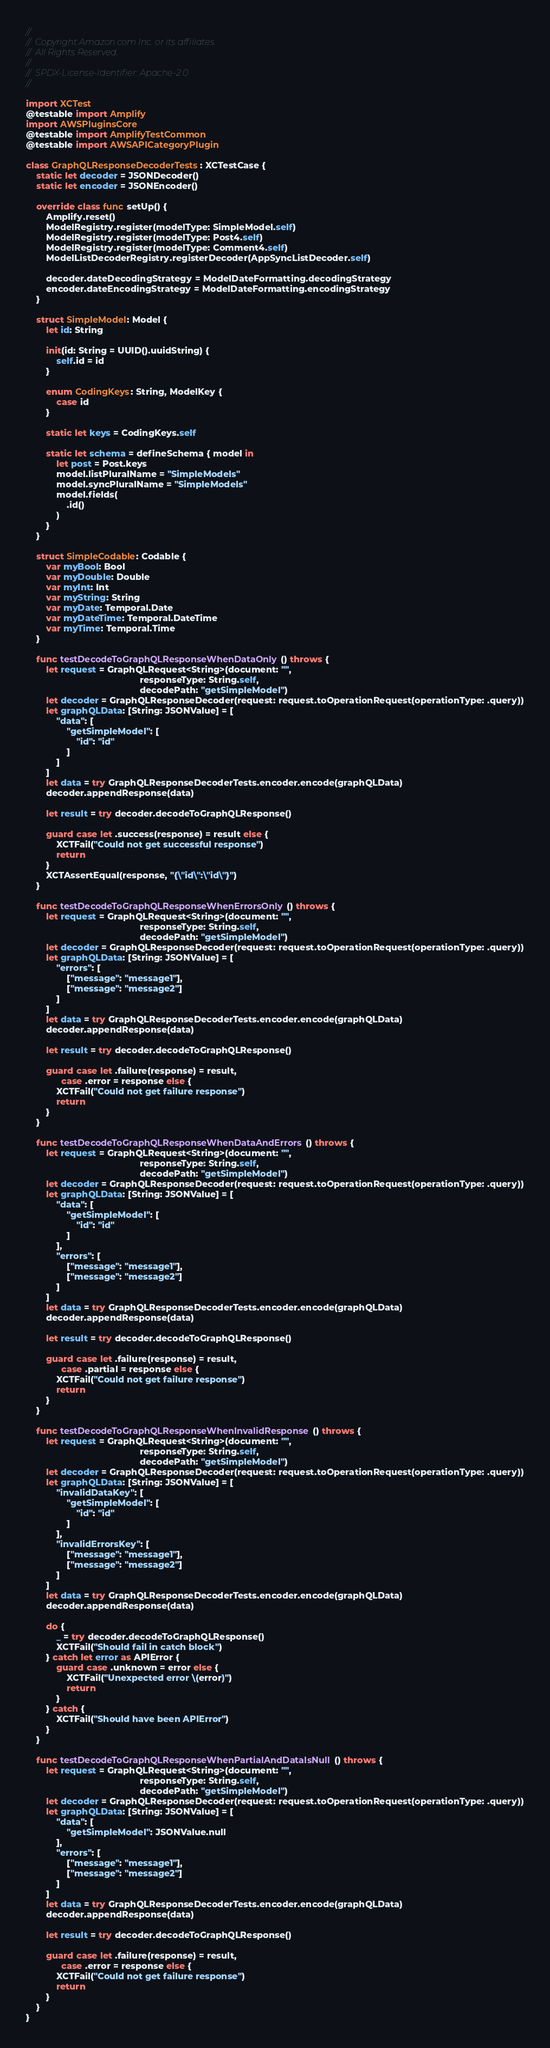Convert code to text. <code><loc_0><loc_0><loc_500><loc_500><_Swift_>//
// Copyright Amazon.com Inc. or its affiliates.
// All Rights Reserved.
//
// SPDX-License-Identifier: Apache-2.0
//

import XCTest
@testable import Amplify
import AWSPluginsCore
@testable import AmplifyTestCommon
@testable import AWSAPICategoryPlugin

class GraphQLResponseDecoderTests: XCTestCase {
    static let decoder = JSONDecoder()
    static let encoder = JSONEncoder()

    override class func setUp() {
        Amplify.reset()
        ModelRegistry.register(modelType: SimpleModel.self)
        ModelRegistry.register(modelType: Post4.self)
        ModelRegistry.register(modelType: Comment4.self)
        ModelListDecoderRegistry.registerDecoder(AppSyncListDecoder.self)

        decoder.dateDecodingStrategy = ModelDateFormatting.decodingStrategy
        encoder.dateEncodingStrategy = ModelDateFormatting.encodingStrategy
    }

    struct SimpleModel: Model {
        let id: String

        init(id: String = UUID().uuidString) {
            self.id = id
        }

        enum CodingKeys: String, ModelKey {
            case id
        }

        static let keys = CodingKeys.self

        static let schema = defineSchema { model in
            let post = Post.keys
            model.listPluralName = "SimpleModels"
            model.syncPluralName = "SimpleModels"
            model.fields(
                .id()
            )
        }
    }

    struct SimpleCodable: Codable {
        var myBool: Bool
        var myDouble: Double
        var myInt: Int
        var myString: String
        var myDate: Temporal.Date
        var myDateTime: Temporal.DateTime
        var myTime: Temporal.Time
    }

    func testDecodeToGraphQLResponseWhenDataOnly() throws {
        let request = GraphQLRequest<String>(document: "",
                                             responseType: String.self,
                                             decodePath: "getSimpleModel")
        let decoder = GraphQLResponseDecoder(request: request.toOperationRequest(operationType: .query))
        let graphQLData: [String: JSONValue] = [
            "data": [
                "getSimpleModel": [
                    "id": "id"
                ]
            ]
        ]
        let data = try GraphQLResponseDecoderTests.encoder.encode(graphQLData)
        decoder.appendResponse(data)

        let result = try decoder.decodeToGraphQLResponse()

        guard case let .success(response) = result else {
            XCTFail("Could not get successful response")
            return
        }
        XCTAssertEqual(response, "{\"id\":\"id\"}")
    }

    func testDecodeToGraphQLResponseWhenErrorsOnly() throws {
        let request = GraphQLRequest<String>(document: "",
                                             responseType: String.self,
                                             decodePath: "getSimpleModel")
        let decoder = GraphQLResponseDecoder(request: request.toOperationRequest(operationType: .query))
        let graphQLData: [String: JSONValue] = [
            "errors": [
                ["message": "message1"],
                ["message": "message2"]
            ]
        ]
        let data = try GraphQLResponseDecoderTests.encoder.encode(graphQLData)
        decoder.appendResponse(data)

        let result = try decoder.decodeToGraphQLResponse()

        guard case let .failure(response) = result,
              case .error = response else {
            XCTFail("Could not get failure response")
            return
        }
    }

    func testDecodeToGraphQLResponseWhenDataAndErrors() throws {
        let request = GraphQLRequest<String>(document: "",
                                             responseType: String.self,
                                             decodePath: "getSimpleModel")
        let decoder = GraphQLResponseDecoder(request: request.toOperationRequest(operationType: .query))
        let graphQLData: [String: JSONValue] = [
            "data": [
                "getSimpleModel": [
                    "id": "id"
                ]
            ],
            "errors": [
                ["message": "message1"],
                ["message": "message2"]
            ]
        ]
        let data = try GraphQLResponseDecoderTests.encoder.encode(graphQLData)
        decoder.appendResponse(data)

        let result = try decoder.decodeToGraphQLResponse()

        guard case let .failure(response) = result,
              case .partial = response else {
            XCTFail("Could not get failure response")
            return
        }
    }

    func testDecodeToGraphQLResponseWhenInvalidResponse() throws {
        let request = GraphQLRequest<String>(document: "",
                                             responseType: String.self,
                                             decodePath: "getSimpleModel")
        let decoder = GraphQLResponseDecoder(request: request.toOperationRequest(operationType: .query))
        let graphQLData: [String: JSONValue] = [
            "invalidDataKey": [
                "getSimpleModel": [
                    "id": "id"
                ]
            ],
            "invalidErrorsKey": [
                ["message": "message1"],
                ["message": "message2"]
            ]
        ]
        let data = try GraphQLResponseDecoderTests.encoder.encode(graphQLData)
        decoder.appendResponse(data)

        do {
            _ = try decoder.decodeToGraphQLResponse()
            XCTFail("Should fail in catch block")
        } catch let error as APIError {
            guard case .unknown = error else {
                XCTFail("Unexpected error \(error)")
                return
            }
        } catch {
            XCTFail("Should have been APIError")
        }
    }

    func testDecodeToGraphQLResponseWhenPartialAndDataIsNull() throws {
        let request = GraphQLRequest<String>(document: "",
                                             responseType: String.self,
                                             decodePath: "getSimpleModel")
        let decoder = GraphQLResponseDecoder(request: request.toOperationRequest(operationType: .query))
        let graphQLData: [String: JSONValue] = [
            "data": [
                "getSimpleModel": JSONValue.null
            ],
            "errors": [
                ["message": "message1"],
                ["message": "message2"]
            ]
        ]
        let data = try GraphQLResponseDecoderTests.encoder.encode(graphQLData)
        decoder.appendResponse(data)

        let result = try decoder.decodeToGraphQLResponse()

        guard case let .failure(response) = result,
              case .error = response else {
            XCTFail("Could not get failure response")
            return
        }
    }
}
</code> 